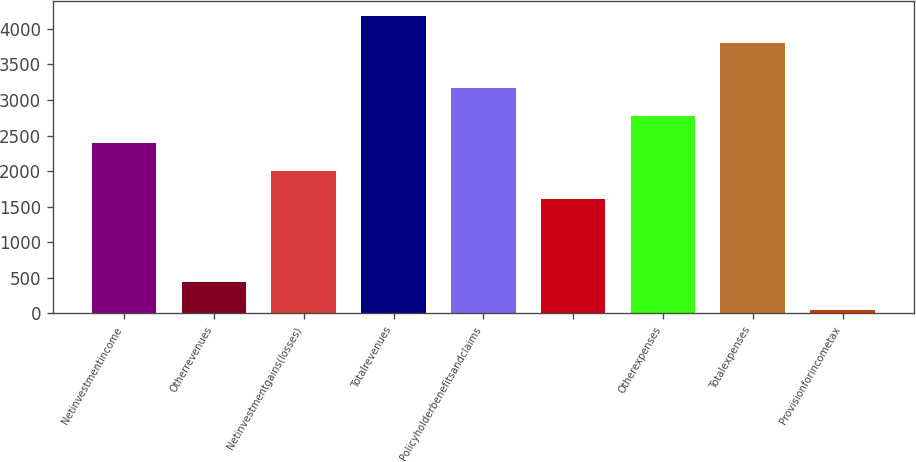<chart> <loc_0><loc_0><loc_500><loc_500><bar_chart><fcel>Netinvestmentincome<fcel>Otherrevenues<fcel>Netinvestmentgains(losses)<fcel>Totalrevenues<fcel>Policyholderbenefitsandclaims<fcel>Unnamed: 5<fcel>Otherexpenses<fcel>Totalexpenses<fcel>Provisionforincometax<nl><fcel>2392.4<fcel>442.9<fcel>2002.5<fcel>4185.9<fcel>3172.2<fcel>1612.6<fcel>2782.3<fcel>3796<fcel>53<nl></chart> 